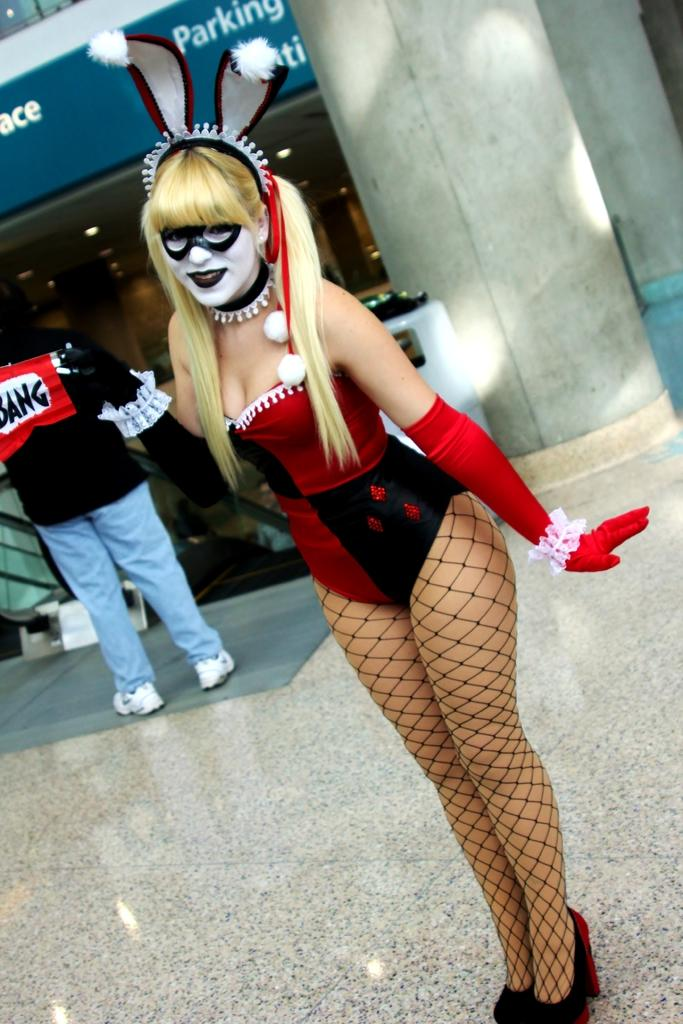What is the cosplayer wearing in the image? The cosplayer is wearing a red dress in the image. Where is the cosplayer positioned in the image? The cosplayer is standing in the middle of the image. Who else is present in the image? There is another person standing on the left side of the image. What can be seen on the right side of the image? There are pillars on the right side of the image. What type of toy is the cosplayer playing with in the image? There is no toy present in the image, and the cosplayer is not shown playing with any toy. 